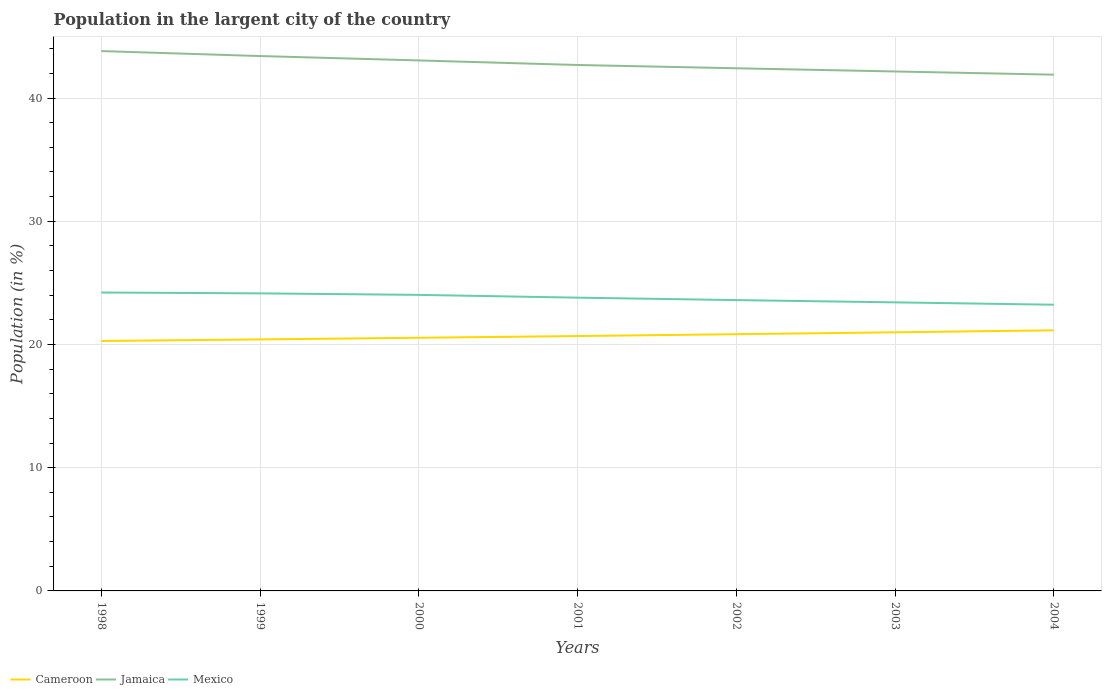Does the line corresponding to Cameroon intersect with the line corresponding to Mexico?
Give a very brief answer. No. Across all years, what is the maximum percentage of population in the largent city in Cameroon?
Give a very brief answer. 20.28. What is the total percentage of population in the largent city in Cameroon in the graph?
Your answer should be very brief. -0.27. What is the difference between the highest and the second highest percentage of population in the largent city in Cameroon?
Offer a very short reply. 0.87. What is the difference between the highest and the lowest percentage of population in the largent city in Jamaica?
Give a very brief answer. 3. Is the percentage of population in the largent city in Cameroon strictly greater than the percentage of population in the largent city in Mexico over the years?
Offer a terse response. Yes. How many lines are there?
Give a very brief answer. 3. How many years are there in the graph?
Your response must be concise. 7. What is the difference between two consecutive major ticks on the Y-axis?
Give a very brief answer. 10. Are the values on the major ticks of Y-axis written in scientific E-notation?
Your answer should be compact. No. Does the graph contain grids?
Give a very brief answer. Yes. Where does the legend appear in the graph?
Ensure brevity in your answer.  Bottom left. How many legend labels are there?
Provide a succinct answer. 3. How are the legend labels stacked?
Make the answer very short. Horizontal. What is the title of the graph?
Your answer should be compact. Population in the largent city of the country. What is the label or title of the X-axis?
Provide a short and direct response. Years. What is the label or title of the Y-axis?
Make the answer very short. Population (in %). What is the Population (in %) of Cameroon in 1998?
Ensure brevity in your answer.  20.28. What is the Population (in %) of Jamaica in 1998?
Provide a short and direct response. 43.81. What is the Population (in %) of Mexico in 1998?
Offer a terse response. 24.22. What is the Population (in %) in Cameroon in 1999?
Give a very brief answer. 20.41. What is the Population (in %) in Jamaica in 1999?
Your answer should be compact. 43.41. What is the Population (in %) of Mexico in 1999?
Give a very brief answer. 24.15. What is the Population (in %) in Cameroon in 2000?
Provide a succinct answer. 20.54. What is the Population (in %) of Jamaica in 2000?
Make the answer very short. 43.05. What is the Population (in %) in Mexico in 2000?
Your answer should be compact. 24.03. What is the Population (in %) of Cameroon in 2001?
Make the answer very short. 20.68. What is the Population (in %) of Jamaica in 2001?
Ensure brevity in your answer.  42.68. What is the Population (in %) in Mexico in 2001?
Your response must be concise. 23.8. What is the Population (in %) in Cameroon in 2002?
Your answer should be very brief. 20.83. What is the Population (in %) in Jamaica in 2002?
Your answer should be compact. 42.42. What is the Population (in %) in Mexico in 2002?
Your answer should be very brief. 23.6. What is the Population (in %) of Cameroon in 2003?
Provide a short and direct response. 20.99. What is the Population (in %) in Jamaica in 2003?
Your response must be concise. 42.16. What is the Population (in %) of Mexico in 2003?
Provide a short and direct response. 23.42. What is the Population (in %) in Cameroon in 2004?
Make the answer very short. 21.15. What is the Population (in %) in Jamaica in 2004?
Provide a succinct answer. 41.9. What is the Population (in %) of Mexico in 2004?
Your answer should be very brief. 23.23. Across all years, what is the maximum Population (in %) in Cameroon?
Give a very brief answer. 21.15. Across all years, what is the maximum Population (in %) in Jamaica?
Ensure brevity in your answer.  43.81. Across all years, what is the maximum Population (in %) of Mexico?
Ensure brevity in your answer.  24.22. Across all years, what is the minimum Population (in %) of Cameroon?
Offer a very short reply. 20.28. Across all years, what is the minimum Population (in %) in Jamaica?
Ensure brevity in your answer.  41.9. Across all years, what is the minimum Population (in %) in Mexico?
Your answer should be very brief. 23.23. What is the total Population (in %) of Cameroon in the graph?
Make the answer very short. 144.9. What is the total Population (in %) in Jamaica in the graph?
Your answer should be compact. 299.42. What is the total Population (in %) of Mexico in the graph?
Give a very brief answer. 166.44. What is the difference between the Population (in %) in Cameroon in 1998 and that in 1999?
Provide a short and direct response. -0.13. What is the difference between the Population (in %) in Jamaica in 1998 and that in 1999?
Keep it short and to the point. 0.4. What is the difference between the Population (in %) in Mexico in 1998 and that in 1999?
Your answer should be very brief. 0.07. What is the difference between the Population (in %) in Cameroon in 1998 and that in 2000?
Your answer should be compact. -0.26. What is the difference between the Population (in %) of Jamaica in 1998 and that in 2000?
Provide a short and direct response. 0.76. What is the difference between the Population (in %) in Mexico in 1998 and that in 2000?
Offer a very short reply. 0.19. What is the difference between the Population (in %) of Cameroon in 1998 and that in 2001?
Provide a succinct answer. -0.4. What is the difference between the Population (in %) in Jamaica in 1998 and that in 2001?
Offer a terse response. 1.13. What is the difference between the Population (in %) of Mexico in 1998 and that in 2001?
Ensure brevity in your answer.  0.42. What is the difference between the Population (in %) of Cameroon in 1998 and that in 2002?
Offer a very short reply. -0.55. What is the difference between the Population (in %) in Jamaica in 1998 and that in 2002?
Keep it short and to the point. 1.4. What is the difference between the Population (in %) in Mexico in 1998 and that in 2002?
Offer a terse response. 0.62. What is the difference between the Population (in %) of Cameroon in 1998 and that in 2003?
Your answer should be compact. -0.7. What is the difference between the Population (in %) of Jamaica in 1998 and that in 2003?
Ensure brevity in your answer.  1.66. What is the difference between the Population (in %) of Mexico in 1998 and that in 2003?
Offer a terse response. 0.8. What is the difference between the Population (in %) of Cameroon in 1998 and that in 2004?
Provide a succinct answer. -0.87. What is the difference between the Population (in %) of Jamaica in 1998 and that in 2004?
Ensure brevity in your answer.  1.91. What is the difference between the Population (in %) in Mexico in 1998 and that in 2004?
Give a very brief answer. 0.99. What is the difference between the Population (in %) of Cameroon in 1999 and that in 2000?
Provide a succinct answer. -0.13. What is the difference between the Population (in %) in Jamaica in 1999 and that in 2000?
Offer a terse response. 0.36. What is the difference between the Population (in %) of Mexico in 1999 and that in 2000?
Give a very brief answer. 0.12. What is the difference between the Population (in %) of Cameroon in 1999 and that in 2001?
Make the answer very short. -0.27. What is the difference between the Population (in %) of Jamaica in 1999 and that in 2001?
Your answer should be compact. 0.73. What is the difference between the Population (in %) of Mexico in 1999 and that in 2001?
Offer a very short reply. 0.35. What is the difference between the Population (in %) of Cameroon in 1999 and that in 2002?
Make the answer very short. -0.42. What is the difference between the Population (in %) of Jamaica in 1999 and that in 2002?
Ensure brevity in your answer.  0.99. What is the difference between the Population (in %) in Mexico in 1999 and that in 2002?
Offer a very short reply. 0.55. What is the difference between the Population (in %) in Cameroon in 1999 and that in 2003?
Provide a succinct answer. -0.58. What is the difference between the Population (in %) in Jamaica in 1999 and that in 2003?
Your answer should be very brief. 1.25. What is the difference between the Population (in %) of Mexico in 1999 and that in 2003?
Ensure brevity in your answer.  0.73. What is the difference between the Population (in %) in Cameroon in 1999 and that in 2004?
Your response must be concise. -0.74. What is the difference between the Population (in %) of Jamaica in 1999 and that in 2004?
Provide a succinct answer. 1.51. What is the difference between the Population (in %) in Mexico in 1999 and that in 2004?
Make the answer very short. 0.92. What is the difference between the Population (in %) of Cameroon in 2000 and that in 2001?
Keep it short and to the point. -0.14. What is the difference between the Population (in %) of Jamaica in 2000 and that in 2001?
Your answer should be very brief. 0.37. What is the difference between the Population (in %) of Mexico in 2000 and that in 2001?
Provide a succinct answer. 0.23. What is the difference between the Population (in %) of Cameroon in 2000 and that in 2002?
Provide a short and direct response. -0.29. What is the difference between the Population (in %) in Jamaica in 2000 and that in 2002?
Your answer should be very brief. 0.64. What is the difference between the Population (in %) in Mexico in 2000 and that in 2002?
Your response must be concise. 0.42. What is the difference between the Population (in %) in Cameroon in 2000 and that in 2003?
Offer a terse response. -0.44. What is the difference between the Population (in %) of Jamaica in 2000 and that in 2003?
Make the answer very short. 0.9. What is the difference between the Population (in %) in Mexico in 2000 and that in 2003?
Offer a terse response. 0.61. What is the difference between the Population (in %) of Cameroon in 2000 and that in 2004?
Provide a succinct answer. -0.61. What is the difference between the Population (in %) of Jamaica in 2000 and that in 2004?
Provide a short and direct response. 1.15. What is the difference between the Population (in %) of Mexico in 2000 and that in 2004?
Give a very brief answer. 0.8. What is the difference between the Population (in %) of Cameroon in 2001 and that in 2002?
Provide a succinct answer. -0.15. What is the difference between the Population (in %) of Jamaica in 2001 and that in 2002?
Offer a terse response. 0.27. What is the difference between the Population (in %) of Mexico in 2001 and that in 2002?
Give a very brief answer. 0.2. What is the difference between the Population (in %) in Cameroon in 2001 and that in 2003?
Your answer should be very brief. -0.3. What is the difference between the Population (in %) of Jamaica in 2001 and that in 2003?
Offer a very short reply. 0.53. What is the difference between the Population (in %) of Mexico in 2001 and that in 2003?
Give a very brief answer. 0.38. What is the difference between the Population (in %) in Cameroon in 2001 and that in 2004?
Your response must be concise. -0.47. What is the difference between the Population (in %) of Jamaica in 2001 and that in 2004?
Offer a very short reply. 0.79. What is the difference between the Population (in %) of Mexico in 2001 and that in 2004?
Your response must be concise. 0.57. What is the difference between the Population (in %) of Cameroon in 2002 and that in 2003?
Your response must be concise. -0.16. What is the difference between the Population (in %) in Jamaica in 2002 and that in 2003?
Offer a terse response. 0.26. What is the difference between the Population (in %) of Mexico in 2002 and that in 2003?
Provide a short and direct response. 0.18. What is the difference between the Population (in %) of Cameroon in 2002 and that in 2004?
Your answer should be very brief. -0.32. What is the difference between the Population (in %) in Jamaica in 2002 and that in 2004?
Make the answer very short. 0.52. What is the difference between the Population (in %) of Mexico in 2002 and that in 2004?
Give a very brief answer. 0.38. What is the difference between the Population (in %) in Cameroon in 2003 and that in 2004?
Provide a short and direct response. -0.16. What is the difference between the Population (in %) of Jamaica in 2003 and that in 2004?
Your response must be concise. 0.26. What is the difference between the Population (in %) in Mexico in 2003 and that in 2004?
Your answer should be compact. 0.19. What is the difference between the Population (in %) in Cameroon in 1998 and the Population (in %) in Jamaica in 1999?
Give a very brief answer. -23.12. What is the difference between the Population (in %) in Cameroon in 1998 and the Population (in %) in Mexico in 1999?
Ensure brevity in your answer.  -3.86. What is the difference between the Population (in %) of Jamaica in 1998 and the Population (in %) of Mexico in 1999?
Provide a succinct answer. 19.66. What is the difference between the Population (in %) of Cameroon in 1998 and the Population (in %) of Jamaica in 2000?
Your answer should be compact. -22.77. What is the difference between the Population (in %) in Cameroon in 1998 and the Population (in %) in Mexico in 2000?
Offer a terse response. -3.74. What is the difference between the Population (in %) in Jamaica in 1998 and the Population (in %) in Mexico in 2000?
Give a very brief answer. 19.79. What is the difference between the Population (in %) in Cameroon in 1998 and the Population (in %) in Jamaica in 2001?
Make the answer very short. -22.4. What is the difference between the Population (in %) of Cameroon in 1998 and the Population (in %) of Mexico in 2001?
Ensure brevity in your answer.  -3.52. What is the difference between the Population (in %) of Jamaica in 1998 and the Population (in %) of Mexico in 2001?
Offer a very short reply. 20.01. What is the difference between the Population (in %) of Cameroon in 1998 and the Population (in %) of Jamaica in 2002?
Provide a short and direct response. -22.13. What is the difference between the Population (in %) in Cameroon in 1998 and the Population (in %) in Mexico in 2002?
Your answer should be very brief. -3.32. What is the difference between the Population (in %) in Jamaica in 1998 and the Population (in %) in Mexico in 2002?
Give a very brief answer. 20.21. What is the difference between the Population (in %) of Cameroon in 1998 and the Population (in %) of Jamaica in 2003?
Provide a succinct answer. -21.87. What is the difference between the Population (in %) in Cameroon in 1998 and the Population (in %) in Mexico in 2003?
Offer a very short reply. -3.13. What is the difference between the Population (in %) of Jamaica in 1998 and the Population (in %) of Mexico in 2003?
Ensure brevity in your answer.  20.39. What is the difference between the Population (in %) of Cameroon in 1998 and the Population (in %) of Jamaica in 2004?
Make the answer very short. -21.61. What is the difference between the Population (in %) of Cameroon in 1998 and the Population (in %) of Mexico in 2004?
Ensure brevity in your answer.  -2.94. What is the difference between the Population (in %) of Jamaica in 1998 and the Population (in %) of Mexico in 2004?
Offer a terse response. 20.58. What is the difference between the Population (in %) in Cameroon in 1999 and the Population (in %) in Jamaica in 2000?
Ensure brevity in your answer.  -22.64. What is the difference between the Population (in %) in Cameroon in 1999 and the Population (in %) in Mexico in 2000?
Ensure brevity in your answer.  -3.62. What is the difference between the Population (in %) in Jamaica in 1999 and the Population (in %) in Mexico in 2000?
Give a very brief answer. 19.38. What is the difference between the Population (in %) of Cameroon in 1999 and the Population (in %) of Jamaica in 2001?
Your answer should be compact. -22.27. What is the difference between the Population (in %) in Cameroon in 1999 and the Population (in %) in Mexico in 2001?
Provide a succinct answer. -3.39. What is the difference between the Population (in %) of Jamaica in 1999 and the Population (in %) of Mexico in 2001?
Your answer should be compact. 19.61. What is the difference between the Population (in %) in Cameroon in 1999 and the Population (in %) in Jamaica in 2002?
Make the answer very short. -22.01. What is the difference between the Population (in %) of Cameroon in 1999 and the Population (in %) of Mexico in 2002?
Offer a terse response. -3.19. What is the difference between the Population (in %) of Jamaica in 1999 and the Population (in %) of Mexico in 2002?
Your answer should be very brief. 19.81. What is the difference between the Population (in %) of Cameroon in 1999 and the Population (in %) of Jamaica in 2003?
Your answer should be very brief. -21.75. What is the difference between the Population (in %) in Cameroon in 1999 and the Population (in %) in Mexico in 2003?
Make the answer very short. -3.01. What is the difference between the Population (in %) in Jamaica in 1999 and the Population (in %) in Mexico in 2003?
Offer a terse response. 19.99. What is the difference between the Population (in %) of Cameroon in 1999 and the Population (in %) of Jamaica in 2004?
Keep it short and to the point. -21.49. What is the difference between the Population (in %) of Cameroon in 1999 and the Population (in %) of Mexico in 2004?
Provide a short and direct response. -2.82. What is the difference between the Population (in %) of Jamaica in 1999 and the Population (in %) of Mexico in 2004?
Keep it short and to the point. 20.18. What is the difference between the Population (in %) in Cameroon in 2000 and the Population (in %) in Jamaica in 2001?
Provide a short and direct response. -22.14. What is the difference between the Population (in %) in Cameroon in 2000 and the Population (in %) in Mexico in 2001?
Make the answer very short. -3.26. What is the difference between the Population (in %) in Jamaica in 2000 and the Population (in %) in Mexico in 2001?
Give a very brief answer. 19.25. What is the difference between the Population (in %) in Cameroon in 2000 and the Population (in %) in Jamaica in 2002?
Keep it short and to the point. -21.87. What is the difference between the Population (in %) of Cameroon in 2000 and the Population (in %) of Mexico in 2002?
Your response must be concise. -3.06. What is the difference between the Population (in %) in Jamaica in 2000 and the Population (in %) in Mexico in 2002?
Keep it short and to the point. 19.45. What is the difference between the Population (in %) in Cameroon in 2000 and the Population (in %) in Jamaica in 2003?
Give a very brief answer. -21.61. What is the difference between the Population (in %) in Cameroon in 2000 and the Population (in %) in Mexico in 2003?
Your response must be concise. -2.87. What is the difference between the Population (in %) in Jamaica in 2000 and the Population (in %) in Mexico in 2003?
Give a very brief answer. 19.63. What is the difference between the Population (in %) in Cameroon in 2000 and the Population (in %) in Jamaica in 2004?
Give a very brief answer. -21.35. What is the difference between the Population (in %) of Cameroon in 2000 and the Population (in %) of Mexico in 2004?
Offer a terse response. -2.68. What is the difference between the Population (in %) in Jamaica in 2000 and the Population (in %) in Mexico in 2004?
Your answer should be compact. 19.82. What is the difference between the Population (in %) in Cameroon in 2001 and the Population (in %) in Jamaica in 2002?
Ensure brevity in your answer.  -21.73. What is the difference between the Population (in %) of Cameroon in 2001 and the Population (in %) of Mexico in 2002?
Provide a succinct answer. -2.92. What is the difference between the Population (in %) in Jamaica in 2001 and the Population (in %) in Mexico in 2002?
Your answer should be compact. 19.08. What is the difference between the Population (in %) in Cameroon in 2001 and the Population (in %) in Jamaica in 2003?
Keep it short and to the point. -21.47. What is the difference between the Population (in %) in Cameroon in 2001 and the Population (in %) in Mexico in 2003?
Give a very brief answer. -2.73. What is the difference between the Population (in %) in Jamaica in 2001 and the Population (in %) in Mexico in 2003?
Offer a terse response. 19.26. What is the difference between the Population (in %) in Cameroon in 2001 and the Population (in %) in Jamaica in 2004?
Offer a terse response. -21.21. What is the difference between the Population (in %) in Cameroon in 2001 and the Population (in %) in Mexico in 2004?
Your response must be concise. -2.54. What is the difference between the Population (in %) in Jamaica in 2001 and the Population (in %) in Mexico in 2004?
Provide a succinct answer. 19.46. What is the difference between the Population (in %) in Cameroon in 2002 and the Population (in %) in Jamaica in 2003?
Your answer should be very brief. -21.32. What is the difference between the Population (in %) of Cameroon in 2002 and the Population (in %) of Mexico in 2003?
Give a very brief answer. -2.58. What is the difference between the Population (in %) in Jamaica in 2002 and the Population (in %) in Mexico in 2003?
Make the answer very short. 19. What is the difference between the Population (in %) in Cameroon in 2002 and the Population (in %) in Jamaica in 2004?
Provide a short and direct response. -21.06. What is the difference between the Population (in %) in Cameroon in 2002 and the Population (in %) in Mexico in 2004?
Provide a short and direct response. -2.39. What is the difference between the Population (in %) in Jamaica in 2002 and the Population (in %) in Mexico in 2004?
Your answer should be compact. 19.19. What is the difference between the Population (in %) in Cameroon in 2003 and the Population (in %) in Jamaica in 2004?
Your response must be concise. -20.91. What is the difference between the Population (in %) of Cameroon in 2003 and the Population (in %) of Mexico in 2004?
Offer a terse response. -2.24. What is the difference between the Population (in %) in Jamaica in 2003 and the Population (in %) in Mexico in 2004?
Make the answer very short. 18.93. What is the average Population (in %) of Cameroon per year?
Make the answer very short. 20.7. What is the average Population (in %) in Jamaica per year?
Keep it short and to the point. 42.77. What is the average Population (in %) in Mexico per year?
Provide a short and direct response. 23.78. In the year 1998, what is the difference between the Population (in %) in Cameroon and Population (in %) in Jamaica?
Your answer should be very brief. -23.53. In the year 1998, what is the difference between the Population (in %) of Cameroon and Population (in %) of Mexico?
Your answer should be very brief. -3.93. In the year 1998, what is the difference between the Population (in %) of Jamaica and Population (in %) of Mexico?
Keep it short and to the point. 19.59. In the year 1999, what is the difference between the Population (in %) in Cameroon and Population (in %) in Jamaica?
Provide a short and direct response. -23. In the year 1999, what is the difference between the Population (in %) of Cameroon and Population (in %) of Mexico?
Provide a short and direct response. -3.74. In the year 1999, what is the difference between the Population (in %) of Jamaica and Population (in %) of Mexico?
Offer a terse response. 19.26. In the year 2000, what is the difference between the Population (in %) in Cameroon and Population (in %) in Jamaica?
Make the answer very short. -22.51. In the year 2000, what is the difference between the Population (in %) in Cameroon and Population (in %) in Mexico?
Give a very brief answer. -3.48. In the year 2000, what is the difference between the Population (in %) of Jamaica and Population (in %) of Mexico?
Keep it short and to the point. 19.03. In the year 2001, what is the difference between the Population (in %) of Cameroon and Population (in %) of Jamaica?
Offer a terse response. -22. In the year 2001, what is the difference between the Population (in %) of Cameroon and Population (in %) of Mexico?
Your response must be concise. -3.11. In the year 2001, what is the difference between the Population (in %) in Jamaica and Population (in %) in Mexico?
Make the answer very short. 18.88. In the year 2002, what is the difference between the Population (in %) of Cameroon and Population (in %) of Jamaica?
Give a very brief answer. -21.58. In the year 2002, what is the difference between the Population (in %) of Cameroon and Population (in %) of Mexico?
Make the answer very short. -2.77. In the year 2002, what is the difference between the Population (in %) in Jamaica and Population (in %) in Mexico?
Your response must be concise. 18.81. In the year 2003, what is the difference between the Population (in %) in Cameroon and Population (in %) in Jamaica?
Provide a short and direct response. -21.17. In the year 2003, what is the difference between the Population (in %) in Cameroon and Population (in %) in Mexico?
Ensure brevity in your answer.  -2.43. In the year 2003, what is the difference between the Population (in %) of Jamaica and Population (in %) of Mexico?
Your response must be concise. 18.74. In the year 2004, what is the difference between the Population (in %) in Cameroon and Population (in %) in Jamaica?
Provide a short and direct response. -20.75. In the year 2004, what is the difference between the Population (in %) in Cameroon and Population (in %) in Mexico?
Offer a very short reply. -2.08. In the year 2004, what is the difference between the Population (in %) in Jamaica and Population (in %) in Mexico?
Your answer should be very brief. 18.67. What is the ratio of the Population (in %) in Jamaica in 1998 to that in 1999?
Offer a very short reply. 1.01. What is the ratio of the Population (in %) in Mexico in 1998 to that in 1999?
Your answer should be compact. 1. What is the ratio of the Population (in %) of Cameroon in 1998 to that in 2000?
Offer a terse response. 0.99. What is the ratio of the Population (in %) of Jamaica in 1998 to that in 2000?
Give a very brief answer. 1.02. What is the ratio of the Population (in %) in Cameroon in 1998 to that in 2001?
Your answer should be compact. 0.98. What is the ratio of the Population (in %) in Jamaica in 1998 to that in 2001?
Your answer should be compact. 1.03. What is the ratio of the Population (in %) of Mexico in 1998 to that in 2001?
Your response must be concise. 1.02. What is the ratio of the Population (in %) of Cameroon in 1998 to that in 2002?
Your answer should be compact. 0.97. What is the ratio of the Population (in %) of Jamaica in 1998 to that in 2002?
Make the answer very short. 1.03. What is the ratio of the Population (in %) of Mexico in 1998 to that in 2002?
Your response must be concise. 1.03. What is the ratio of the Population (in %) of Cameroon in 1998 to that in 2003?
Your answer should be compact. 0.97. What is the ratio of the Population (in %) of Jamaica in 1998 to that in 2003?
Keep it short and to the point. 1.04. What is the ratio of the Population (in %) in Mexico in 1998 to that in 2003?
Provide a succinct answer. 1.03. What is the ratio of the Population (in %) in Cameroon in 1998 to that in 2004?
Ensure brevity in your answer.  0.96. What is the ratio of the Population (in %) in Jamaica in 1998 to that in 2004?
Your answer should be compact. 1.05. What is the ratio of the Population (in %) in Mexico in 1998 to that in 2004?
Offer a terse response. 1.04. What is the ratio of the Population (in %) of Jamaica in 1999 to that in 2000?
Your response must be concise. 1.01. What is the ratio of the Population (in %) of Cameroon in 1999 to that in 2001?
Keep it short and to the point. 0.99. What is the ratio of the Population (in %) of Jamaica in 1999 to that in 2001?
Provide a short and direct response. 1.02. What is the ratio of the Population (in %) of Mexico in 1999 to that in 2001?
Offer a terse response. 1.01. What is the ratio of the Population (in %) in Cameroon in 1999 to that in 2002?
Your answer should be very brief. 0.98. What is the ratio of the Population (in %) in Jamaica in 1999 to that in 2002?
Offer a very short reply. 1.02. What is the ratio of the Population (in %) in Mexico in 1999 to that in 2002?
Your response must be concise. 1.02. What is the ratio of the Population (in %) in Cameroon in 1999 to that in 2003?
Your answer should be very brief. 0.97. What is the ratio of the Population (in %) in Jamaica in 1999 to that in 2003?
Ensure brevity in your answer.  1.03. What is the ratio of the Population (in %) of Mexico in 1999 to that in 2003?
Your answer should be compact. 1.03. What is the ratio of the Population (in %) in Cameroon in 1999 to that in 2004?
Your answer should be very brief. 0.96. What is the ratio of the Population (in %) of Jamaica in 1999 to that in 2004?
Your answer should be compact. 1.04. What is the ratio of the Population (in %) in Mexico in 1999 to that in 2004?
Give a very brief answer. 1.04. What is the ratio of the Population (in %) of Cameroon in 2000 to that in 2001?
Provide a succinct answer. 0.99. What is the ratio of the Population (in %) of Jamaica in 2000 to that in 2001?
Make the answer very short. 1.01. What is the ratio of the Population (in %) of Mexico in 2000 to that in 2001?
Your answer should be compact. 1.01. What is the ratio of the Population (in %) in Cameroon in 2000 to that in 2002?
Make the answer very short. 0.99. What is the ratio of the Population (in %) in Cameroon in 2000 to that in 2003?
Offer a very short reply. 0.98. What is the ratio of the Population (in %) of Jamaica in 2000 to that in 2003?
Provide a succinct answer. 1.02. What is the ratio of the Population (in %) in Cameroon in 2000 to that in 2004?
Your response must be concise. 0.97. What is the ratio of the Population (in %) in Jamaica in 2000 to that in 2004?
Your response must be concise. 1.03. What is the ratio of the Population (in %) in Mexico in 2000 to that in 2004?
Provide a short and direct response. 1.03. What is the ratio of the Population (in %) in Cameroon in 2001 to that in 2002?
Offer a terse response. 0.99. What is the ratio of the Population (in %) of Mexico in 2001 to that in 2002?
Make the answer very short. 1.01. What is the ratio of the Population (in %) of Cameroon in 2001 to that in 2003?
Your answer should be compact. 0.99. What is the ratio of the Population (in %) in Jamaica in 2001 to that in 2003?
Your answer should be compact. 1.01. What is the ratio of the Population (in %) of Mexico in 2001 to that in 2003?
Your answer should be compact. 1.02. What is the ratio of the Population (in %) of Cameroon in 2001 to that in 2004?
Keep it short and to the point. 0.98. What is the ratio of the Population (in %) of Jamaica in 2001 to that in 2004?
Ensure brevity in your answer.  1.02. What is the ratio of the Population (in %) of Mexico in 2001 to that in 2004?
Ensure brevity in your answer.  1.02. What is the ratio of the Population (in %) in Cameroon in 2002 to that in 2003?
Your answer should be very brief. 0.99. What is the ratio of the Population (in %) in Jamaica in 2002 to that in 2003?
Your answer should be compact. 1.01. What is the ratio of the Population (in %) in Mexico in 2002 to that in 2003?
Your answer should be very brief. 1.01. What is the ratio of the Population (in %) in Jamaica in 2002 to that in 2004?
Your response must be concise. 1.01. What is the ratio of the Population (in %) in Mexico in 2002 to that in 2004?
Offer a very short reply. 1.02. What is the ratio of the Population (in %) of Jamaica in 2003 to that in 2004?
Offer a very short reply. 1.01. What is the ratio of the Population (in %) of Mexico in 2003 to that in 2004?
Provide a short and direct response. 1.01. What is the difference between the highest and the second highest Population (in %) in Cameroon?
Your response must be concise. 0.16. What is the difference between the highest and the second highest Population (in %) of Jamaica?
Keep it short and to the point. 0.4. What is the difference between the highest and the second highest Population (in %) in Mexico?
Your answer should be very brief. 0.07. What is the difference between the highest and the lowest Population (in %) in Cameroon?
Keep it short and to the point. 0.87. What is the difference between the highest and the lowest Population (in %) in Jamaica?
Make the answer very short. 1.91. What is the difference between the highest and the lowest Population (in %) of Mexico?
Your answer should be very brief. 0.99. 